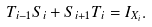<formula> <loc_0><loc_0><loc_500><loc_500>T _ { i - 1 } S _ { i } + S _ { i + 1 } T _ { i } = I _ { X _ { i } } .</formula> 